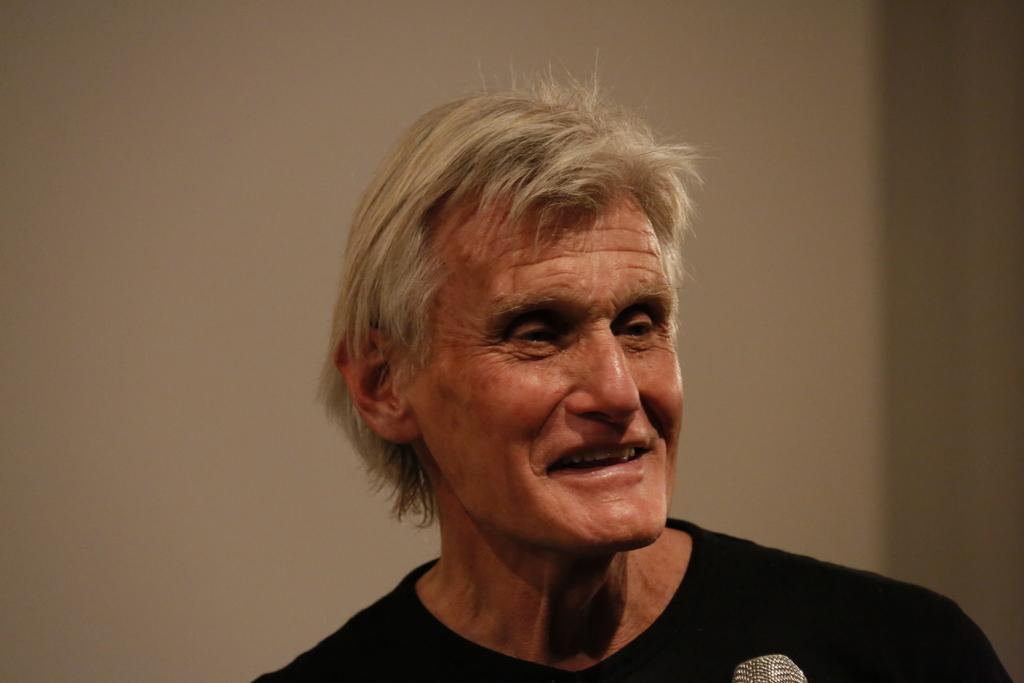What is the main subject of the image? There is a man in the image. Where is the man located in the image? The man is in the middle of the image. What is the man wearing in the image? The man is wearing a t-shirt. What type of patch can be seen on the man's t-shirt in the image? There is no patch visible on the man's t-shirt in the image. How many tickets does the man have in the image? There is no mention of tickets in the image, so it cannot be determined how many the man has. 